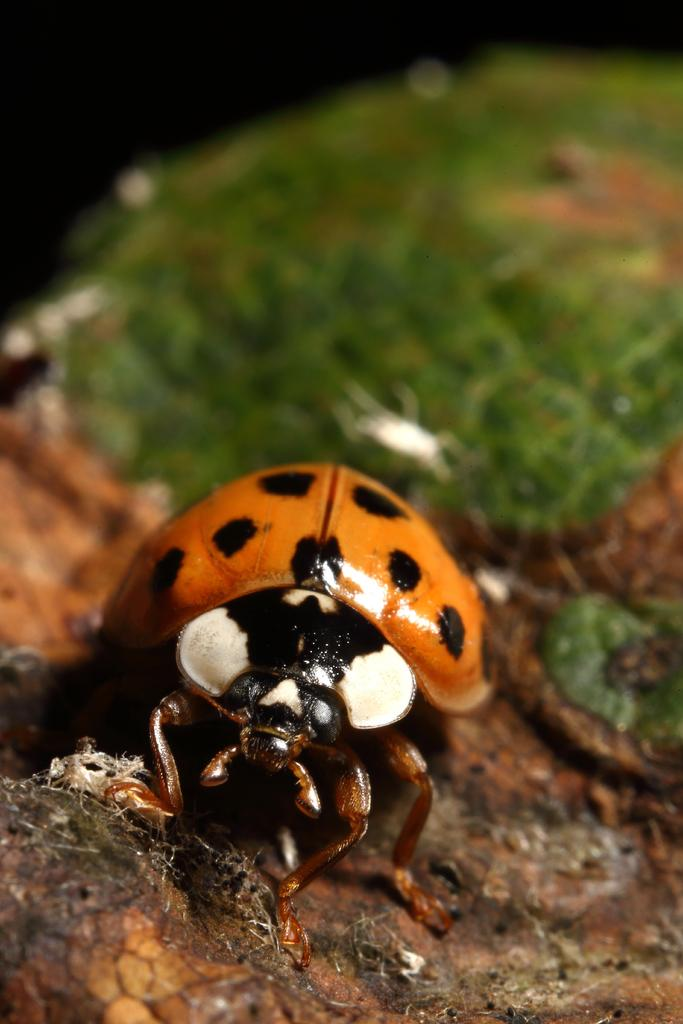What insect is present in the image? There is a ladybug in the image. Where is the ladybug located? The ladybug is on a surface. Can you describe the background of the image? The background of the image is blurry. What type of copper material can be seen in the image? There is no copper material present in the image; it features a ladybug on a surface with a blurry background. 